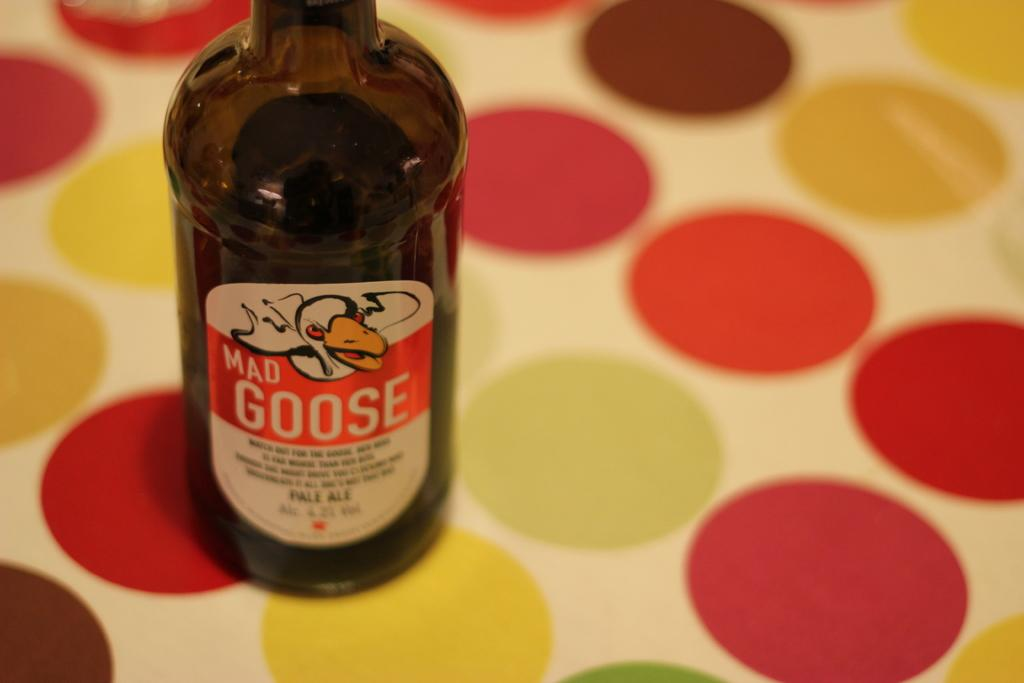Provide a one-sentence caption for the provided image. A bottle of mad goose that is alcoholic in sense. 